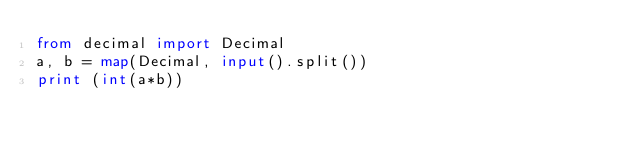<code> <loc_0><loc_0><loc_500><loc_500><_Python_>from decimal import Decimal
a, b = map(Decimal, input().split())
print (int(a*b))</code> 